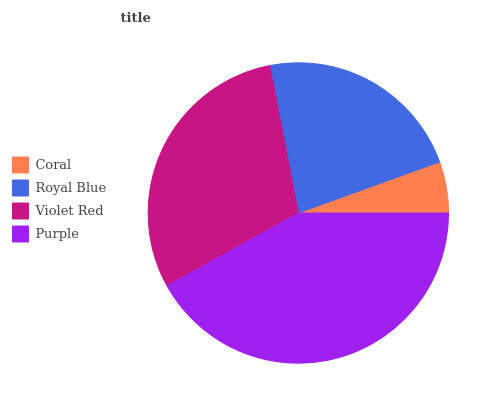Is Coral the minimum?
Answer yes or no. Yes. Is Purple the maximum?
Answer yes or no. Yes. Is Royal Blue the minimum?
Answer yes or no. No. Is Royal Blue the maximum?
Answer yes or no. No. Is Royal Blue greater than Coral?
Answer yes or no. Yes. Is Coral less than Royal Blue?
Answer yes or no. Yes. Is Coral greater than Royal Blue?
Answer yes or no. No. Is Royal Blue less than Coral?
Answer yes or no. No. Is Violet Red the high median?
Answer yes or no. Yes. Is Royal Blue the low median?
Answer yes or no. Yes. Is Purple the high median?
Answer yes or no. No. Is Coral the low median?
Answer yes or no. No. 